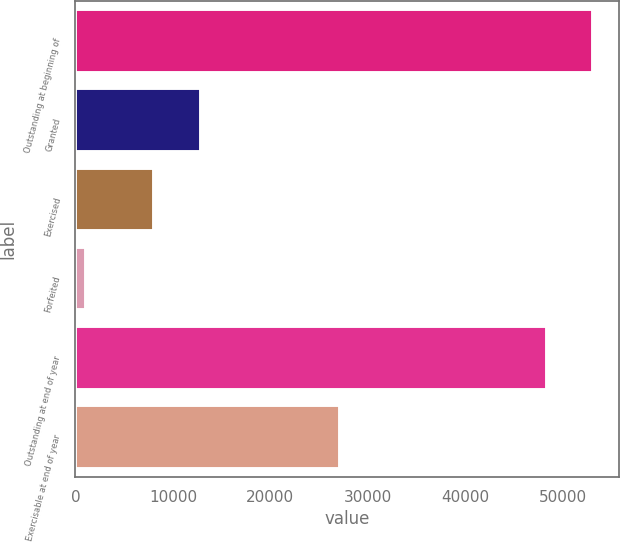Convert chart to OTSL. <chart><loc_0><loc_0><loc_500><loc_500><bar_chart><fcel>Outstanding at beginning of<fcel>Granted<fcel>Exercised<fcel>Forfeited<fcel>Outstanding at end of year<fcel>Exercisable at end of year<nl><fcel>53108.7<fcel>12879.7<fcel>8108<fcel>1055<fcel>48337<fcel>27126<nl></chart> 